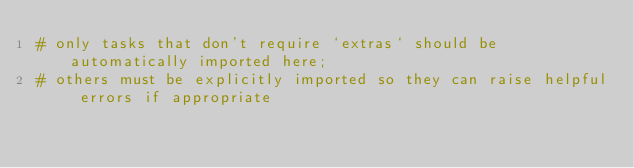Convert code to text. <code><loc_0><loc_0><loc_500><loc_500><_Python_># only tasks that don't require `extras` should be automatically imported here;
# others must be explicitly imported so they can raise helpful errors if appropriate
</code> 